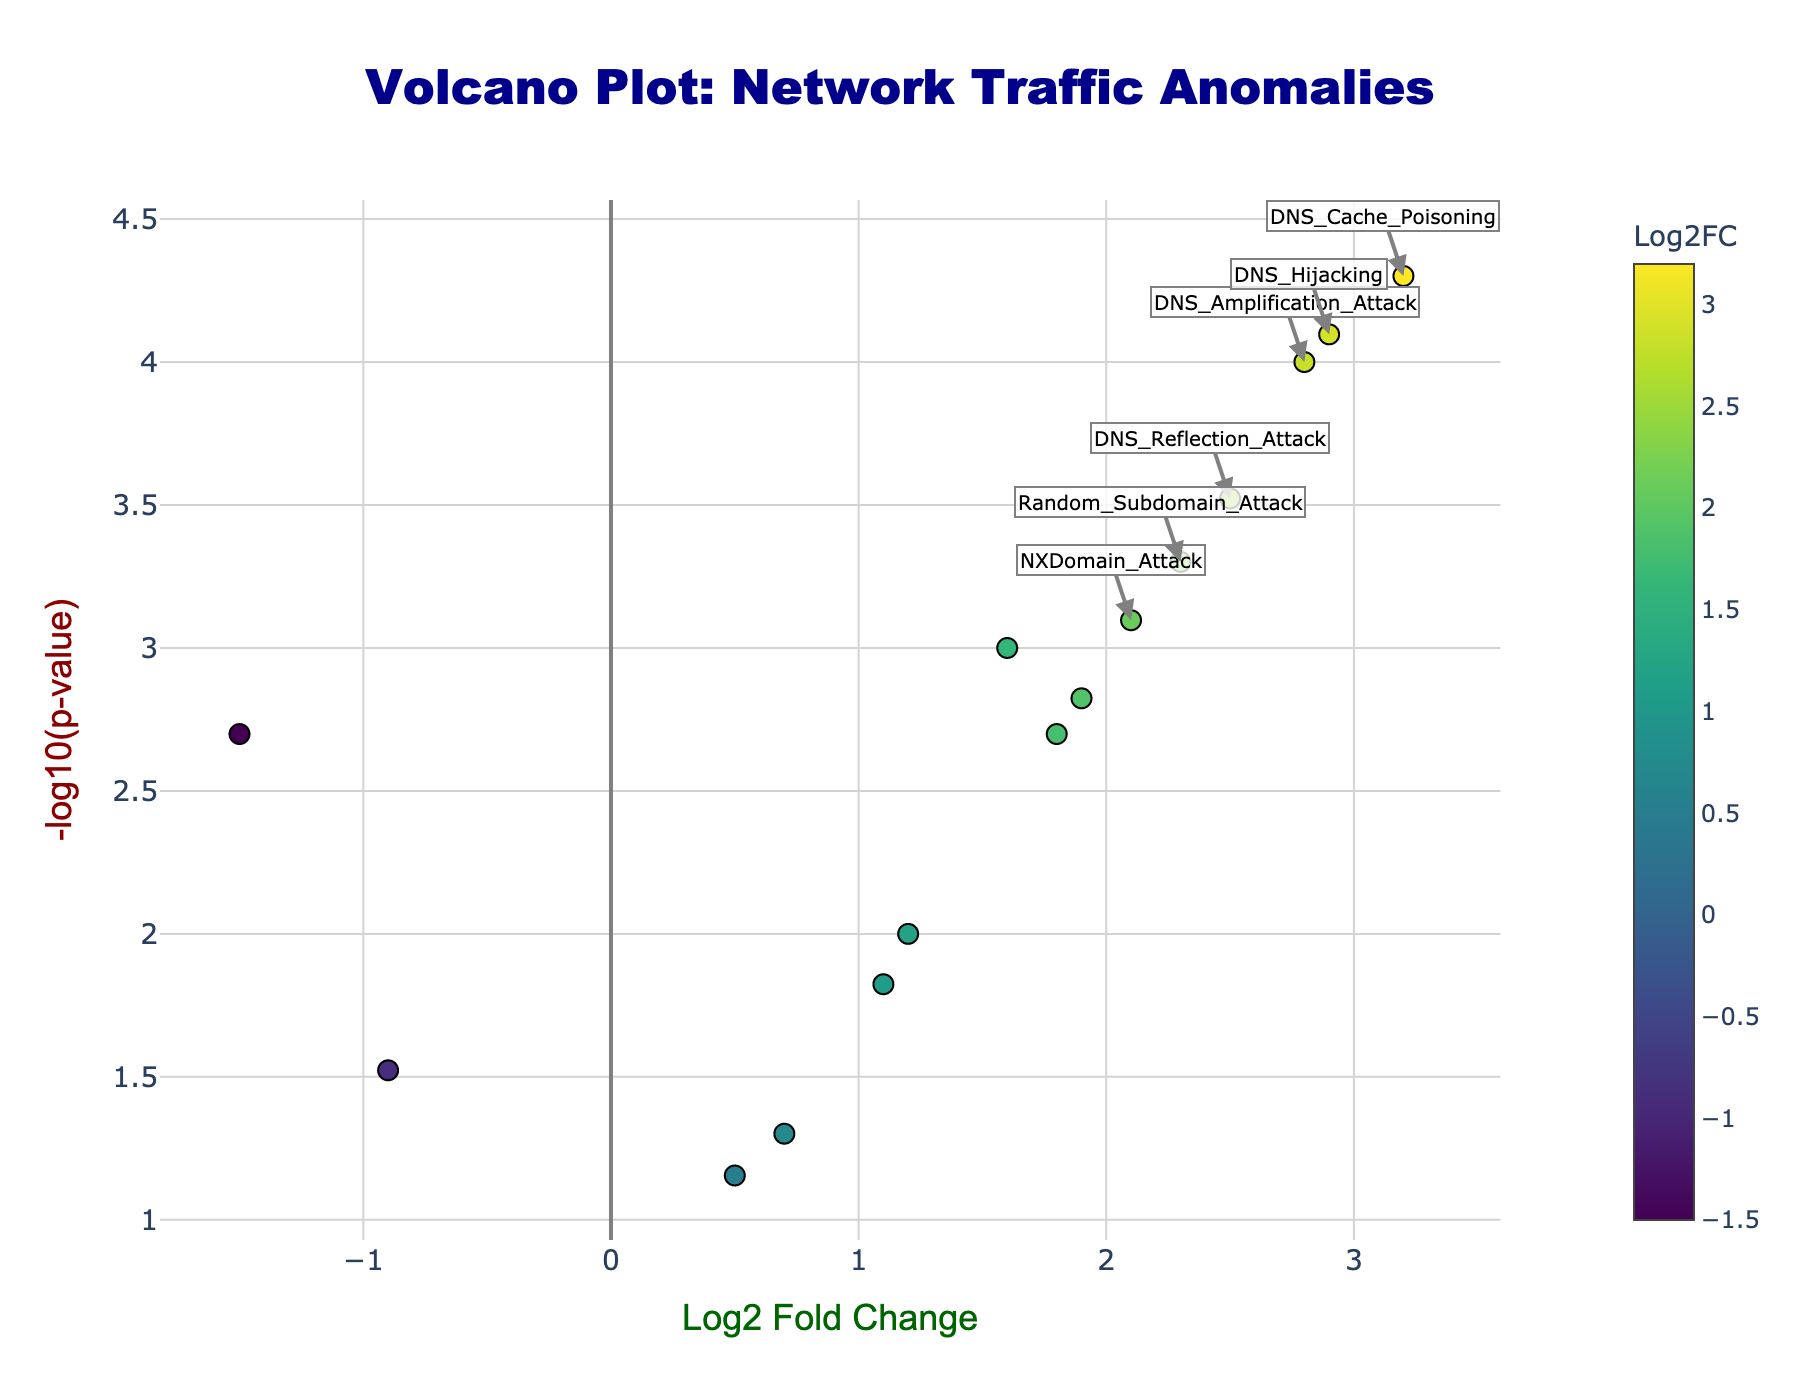What's the title of the figure? The title is present at the top center of the figure in large font size and it reads "Volcano Plot: Network Traffic Anomalies".
Answer: Volcano Plot: Network Traffic Anomalies What are the labels of the x-axis and y-axis? The axes labels are located beside each axis in the figure, with the x-axis labeled "Log2 Fold Change" and the y-axis labeled "-log10(p-value)".
Answer: Log2 Fold Change and -log10(p-value) How many anomalies have a positive Log2 Fold Change? To determine this, count the number of data points with a Log2 Fold Change greater than 0. There are 12 such anomalies.
Answer: 12 Which anomaly has the highest severity as indicated by Log2 Fold Change? By examining the x-axis for the highest positive Log2 Fold Change value, we see that "DNS Cache Poisoning" has the highest Log2 Fold Change of 3.2.
Answer: DNS Cache Poisoning How many anomalies are associated with p-values less than 0.001? Check the y-axis for data points with -log10(p-value) greater than 3, (since -log10(0.001) = 3). There are 6 such anomalies.
Answer: 6 Which anomaly has the lowest frequency of occurrence in terms of Log2 Fold Change? Look for the point with the lowest (most negative) Log2 Fold Change value, which is "SYN Flood" with a Log2 Fold Change of -1.5.
Answer: SYN Flood Compare "DNS Amplification Attack" and "DNS Reflection Attack" in terms of severity and frequency. Which one is higher in each category? "DNS Amplification Attack" has a Log2 Fold Change of 2.8 and "DNS Reflection Attack" has 2.5. The -log10(p-value) for "DNS Amplification Attack" is 4 (since -log10(0.0001) = 4) and for "DNS Reflection Attack" it is 3.52 (since -log10(0.0003) = 3.52). "DNS Amplification Attack" is higher in both severity and frequency.
Answer: DNS Amplification Attack Among the anomalies with Log2 Fold Change greater than 2, which has the highest -log10(p-value)? First identify anomalies with Log2 Fold Change > 2: "DNS Amplification Attack", "DNS Cache Poisoning", "DNS Hijacking", "Random Subdomain Attack". Then compare their -log10(p-values): "DNS Cache Poisoning" has the highest value of 4.3 (since -log10(0.00005) = 4.3).
Answer: DNS Cache Poisoning What are the characteristics of "DNS Hijacking" in terms of Log2 Fold Change and p-value? Locate “DNS Hijacking” which has Log2 Fold Change of 2.9 and a p-value of 0.00008 (since -log10(p-value) = 4.1).
Answer: Log2 Fold Change: 2.9, P-value: 0.00008 